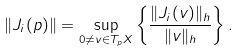<formula> <loc_0><loc_0><loc_500><loc_500>\| J _ { i } ( p ) \| = \sup _ { 0 \neq v \in T _ { p } X } \left \{ \frac { \| J _ { i } ( v ) \| _ { h } } { \| v \| _ { h } } \right \} .</formula> 